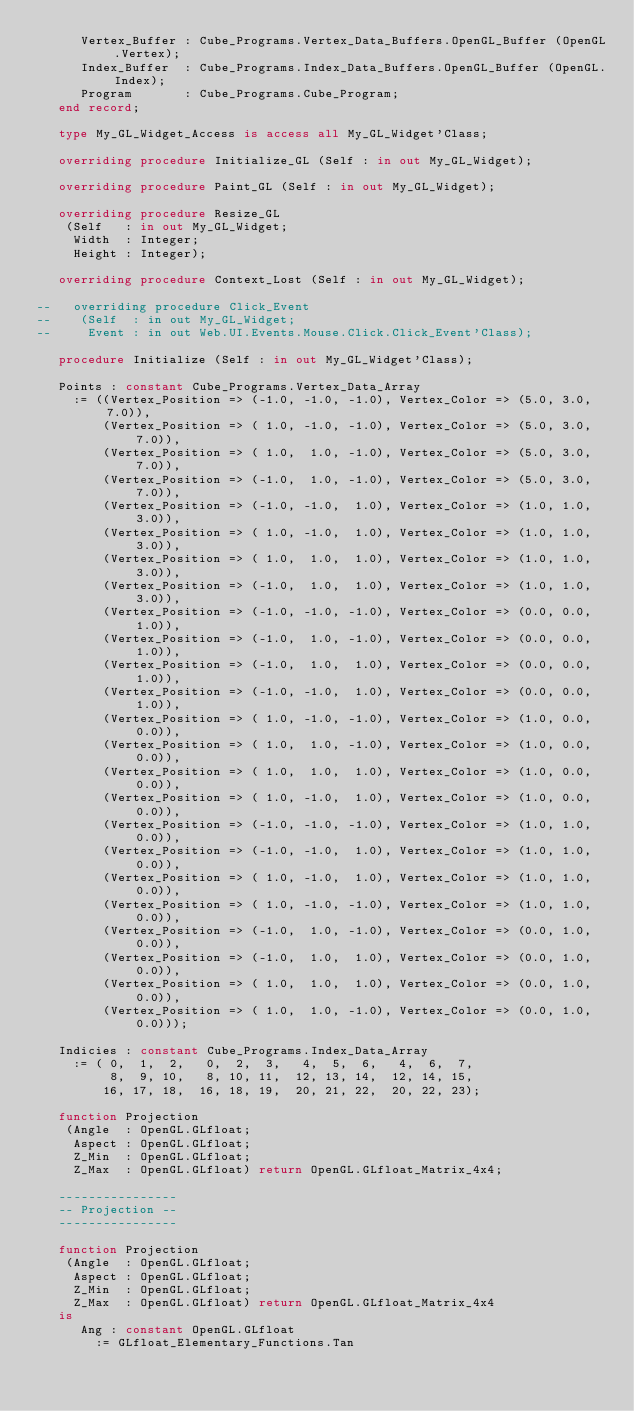<code> <loc_0><loc_0><loc_500><loc_500><_Ada_>      Vertex_Buffer : Cube_Programs.Vertex_Data_Buffers.OpenGL_Buffer (OpenGL.Vertex);
      Index_Buffer  : Cube_Programs.Index_Data_Buffers.OpenGL_Buffer (OpenGL.Index);
      Program       : Cube_Programs.Cube_Program;
   end record;

   type My_GL_Widget_Access is access all My_GL_Widget'Class;

   overriding procedure Initialize_GL (Self : in out My_GL_Widget);

   overriding procedure Paint_GL (Self : in out My_GL_Widget);

   overriding procedure Resize_GL
    (Self   : in out My_GL_Widget;
     Width  : Integer;
     Height : Integer);

   overriding procedure Context_Lost (Self : in out My_GL_Widget);

--   overriding procedure Click_Event
--    (Self  : in out My_GL_Widget;
--     Event : in out Web.UI.Events.Mouse.Click.Click_Event'Class);

   procedure Initialize (Self : in out My_GL_Widget'Class);

   Points : constant Cube_Programs.Vertex_Data_Array
     := ((Vertex_Position => (-1.0, -1.0, -1.0), Vertex_Color => (5.0, 3.0, 7.0)),
         (Vertex_Position => ( 1.0, -1.0, -1.0), Vertex_Color => (5.0, 3.0, 7.0)),
         (Vertex_Position => ( 1.0,  1.0, -1.0), Vertex_Color => (5.0, 3.0, 7.0)),
         (Vertex_Position => (-1.0,  1.0, -1.0), Vertex_Color => (5.0, 3.0, 7.0)),
         (Vertex_Position => (-1.0, -1.0,  1.0), Vertex_Color => (1.0, 1.0, 3.0)),
         (Vertex_Position => ( 1.0, -1.0,  1.0), Vertex_Color => (1.0, 1.0, 3.0)),
         (Vertex_Position => ( 1.0,  1.0,  1.0), Vertex_Color => (1.0, 1.0, 3.0)),
         (Vertex_Position => (-1.0,  1.0,  1.0), Vertex_Color => (1.0, 1.0, 3.0)),
         (Vertex_Position => (-1.0, -1.0, -1.0), Vertex_Color => (0.0, 0.0, 1.0)),
         (Vertex_Position => (-1.0,  1.0, -1.0), Vertex_Color => (0.0, 0.0, 1.0)),
         (Vertex_Position => (-1.0,  1.0,  1.0), Vertex_Color => (0.0, 0.0, 1.0)),
         (Vertex_Position => (-1.0, -1.0,  1.0), Vertex_Color => (0.0, 0.0, 1.0)),
         (Vertex_Position => ( 1.0, -1.0, -1.0), Vertex_Color => (1.0, 0.0, 0.0)),
         (Vertex_Position => ( 1.0,  1.0, -1.0), Vertex_Color => (1.0, 0.0, 0.0)),
         (Vertex_Position => ( 1.0,  1.0,  1.0), Vertex_Color => (1.0, 0.0, 0.0)),
         (Vertex_Position => ( 1.0, -1.0,  1.0), Vertex_Color => (1.0, 0.0, 0.0)),
         (Vertex_Position => (-1.0, -1.0, -1.0), Vertex_Color => (1.0, 1.0, 0.0)),
         (Vertex_Position => (-1.0, -1.0,  1.0), Vertex_Color => (1.0, 1.0, 0.0)),
         (Vertex_Position => ( 1.0, -1.0,  1.0), Vertex_Color => (1.0, 1.0, 0.0)),
         (Vertex_Position => ( 1.0, -1.0, -1.0), Vertex_Color => (1.0, 1.0, 0.0)),
         (Vertex_Position => (-1.0,  1.0, -1.0), Vertex_Color => (0.0, 1.0, 0.0)),
         (Vertex_Position => (-1.0,  1.0,  1.0), Vertex_Color => (0.0, 1.0, 0.0)),
         (Vertex_Position => ( 1.0,  1.0,  1.0), Vertex_Color => (0.0, 1.0, 0.0)),
         (Vertex_Position => ( 1.0,  1.0, -1.0), Vertex_Color => (0.0, 1.0, 0.0)));

   Indicies : constant Cube_Programs.Index_Data_Array
     := ( 0,  1,  2,   0,  2,  3,   4,  5,  6,   4,  6,  7,
          8,  9, 10,   8, 10, 11,  12, 13, 14,  12, 14, 15,
         16, 17, 18,  16, 18, 19,  20, 21, 22,  20, 22, 23);

   function Projection
    (Angle  : OpenGL.GLfloat;
     Aspect : OpenGL.GLfloat;
     Z_Min  : OpenGL.GLfloat;
     Z_Max  : OpenGL.GLfloat) return OpenGL.GLfloat_Matrix_4x4;

   ----------------
   -- Projection --
   ----------------

   function Projection
    (Angle  : OpenGL.GLfloat;
     Aspect : OpenGL.GLfloat;
     Z_Min  : OpenGL.GLfloat;
     Z_Max  : OpenGL.GLfloat) return OpenGL.GLfloat_Matrix_4x4
   is
      Ang : constant OpenGL.GLfloat
        := GLfloat_Elementary_Functions.Tan</code> 